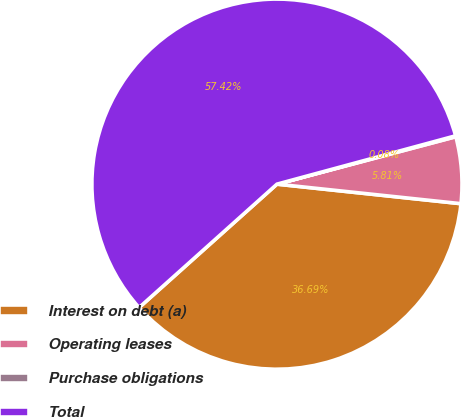Convert chart. <chart><loc_0><loc_0><loc_500><loc_500><pie_chart><fcel>Interest on debt (a)<fcel>Operating leases<fcel>Purchase obligations<fcel>Total<nl><fcel>36.69%<fcel>5.81%<fcel>0.08%<fcel>57.41%<nl></chart> 